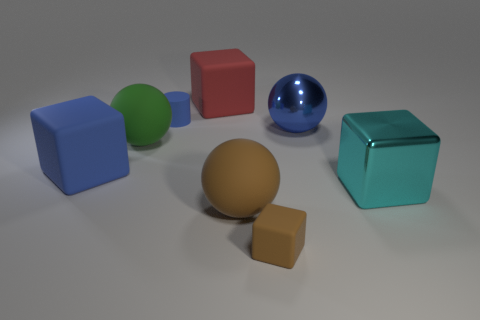Subtract all big cyan blocks. How many blocks are left? 3 Add 1 tiny brown matte cubes. How many objects exist? 9 Subtract all cyan cubes. How many cubes are left? 3 Subtract 1 balls. How many balls are left? 2 Subtract all balls. How many objects are left? 5 Subtract 1 brown spheres. How many objects are left? 7 Subtract all gray cubes. Subtract all yellow spheres. How many cubes are left? 4 Subtract all brown matte objects. Subtract all matte cylinders. How many objects are left? 5 Add 4 small blue rubber objects. How many small blue rubber objects are left? 5 Add 1 blue balls. How many blue balls exist? 2 